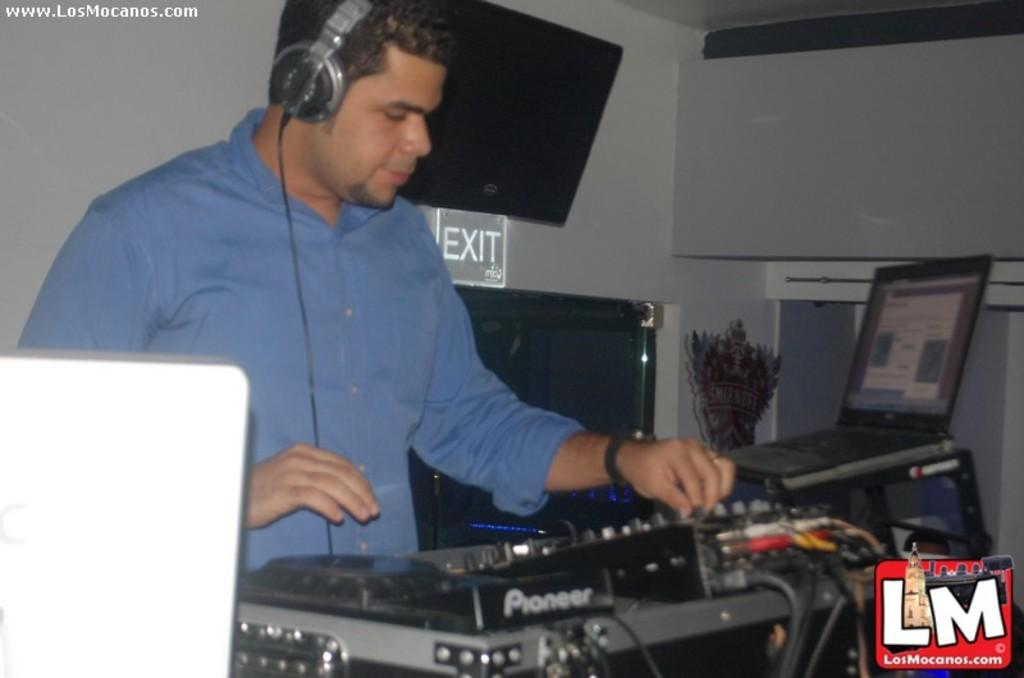Provide a one-sentence caption for the provided image. A disc jockey playing music part of Los Mocanos. 